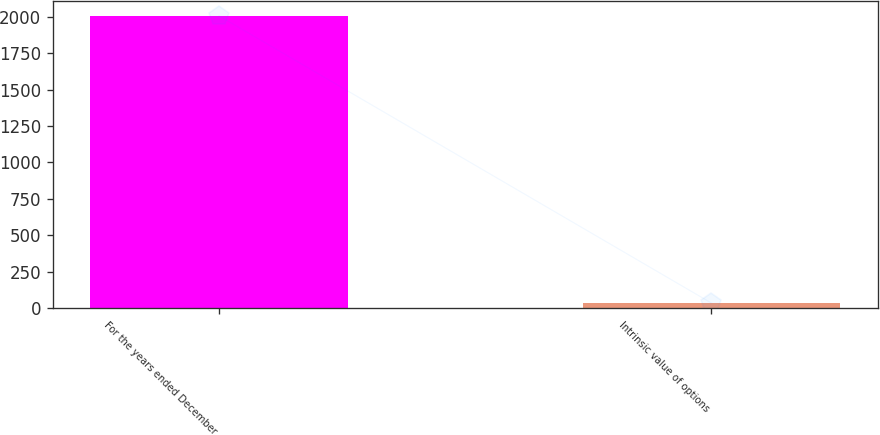Convert chart. <chart><loc_0><loc_0><loc_500><loc_500><bar_chart><fcel>For the years ended December<fcel>Intrinsic value of options<nl><fcel>2007<fcel>34.3<nl></chart> 